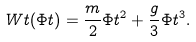<formula> <loc_0><loc_0><loc_500><loc_500>\ W t ( \Phi t ) = \frac { m } { 2 } \Phi t ^ { 2 } + \frac { g } { 3 } \Phi t ^ { 3 } .</formula> 